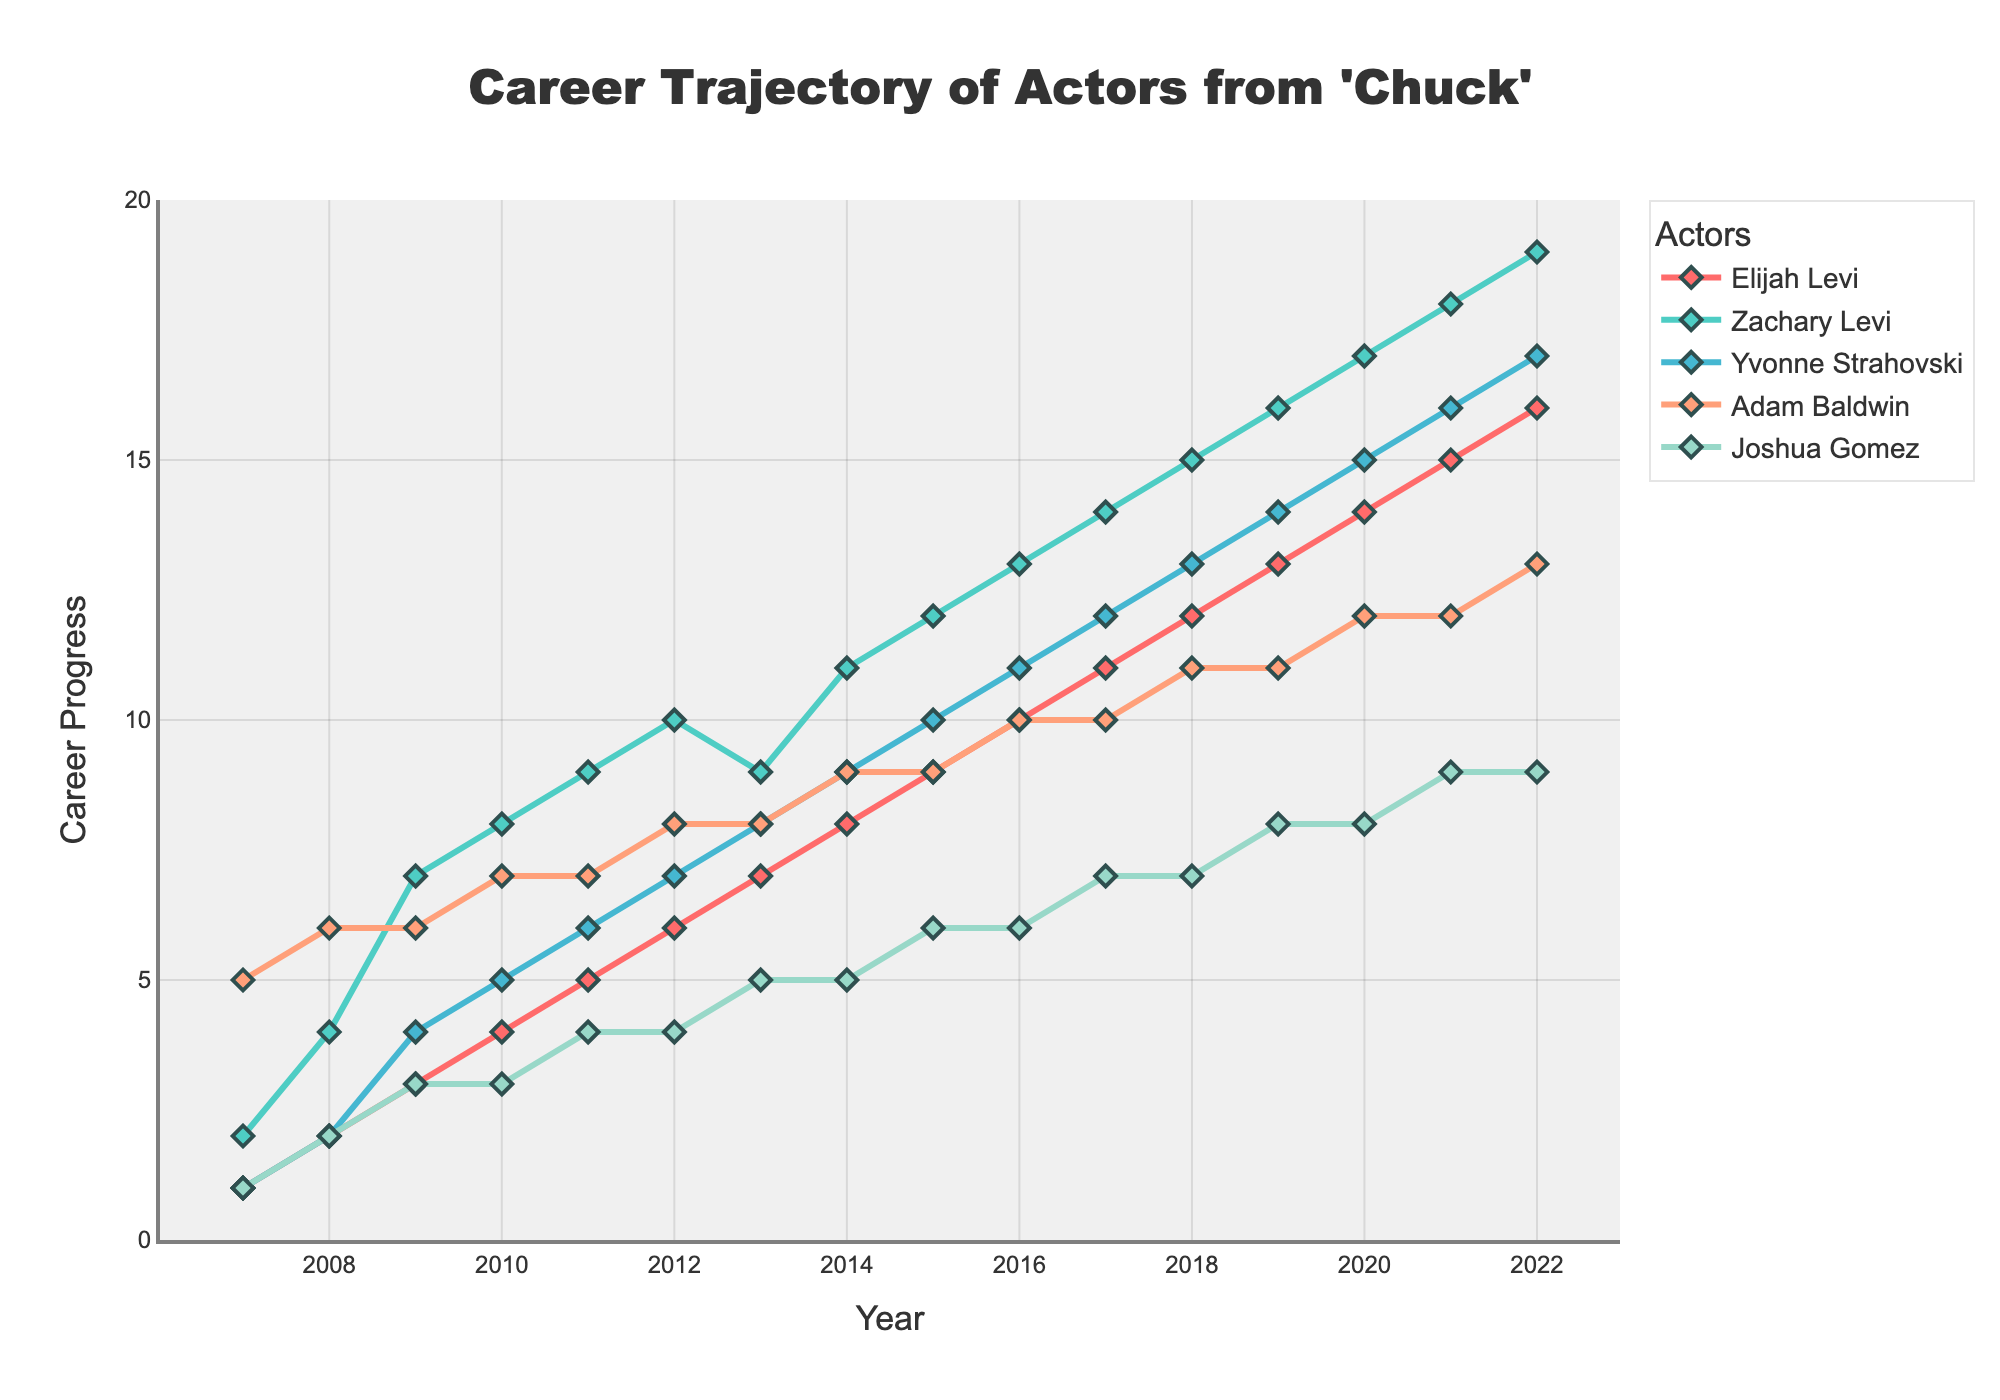Which actor had the highest career progress in 2010? In the year 2010, by examining the heights of the lines, it's clear that Adam Baldwin had the highest career progress as his line is the tallest.
Answer: Adam Baldwin How did Elijah Levi's career progress compare to Joshua Gomez's in 2015? In 2015, Elijah Levi had a career progress of 9, while Joshua Gomez had a career progress of 6. Elijah Levi's progress is greater than Joshua Gomez's.
Answer: Elijah Levi's progress was 3 points higher During which years did Yvonne Strahovski's career progress surpass that of Zachary Levi's? By comparing their trajectories year by year, Yvonne Strahovski's progress surpassed Zachary Levi's in 2007 and 2008 since her line is higher in these years.
Answer: 2007 and 2008 What is the sum of Elijah Levi's career progress in the years 2011 and 2012? The career progress of Elijah Levi in 2011 is 5 and in 2012 is 6. Summing them up: 5 + 6 = 11.
Answer: 11 Which actor showed the most significant increase in career progress between any two consecutive years, and what was the increase? Comparing the increases year by year for all actors, Zachary Levi showed the most significant increase between 2008 and 2009 with an increase of 3 (from 4 to 7).
Answer: Zachary Levi, increase of 3 In which year did Adam Baldwin first see a stall in his career progress? Observing Adam Baldwin's trajectory, he first experienced no increase in career progress from 2009 to 2010 where his value stayed at 6.
Answer: 2010 Who had the lowest career progress in 2020, and what was the value? In 2020, by looking at the heights of the lines, Joshua Gomez had the lowest career progress with a value of 8.
Answer: Joshua Gomez, 8 What is the average career progress of Yvonne Strahovski from 2007 to 2012? Yvonne Strahovski's progress values from 2007 to 2012 are 1, 2, 4, 5, 6, and 7. Summing these values gives 1+2+4+5+6+7 = 25. The average is 25/6 = 4.17.
Answer: 4.17 How many times did Zachary Levi’s career progress exceed 10? By examining Zachary Levi's data points, his career progress exceeded 10 in the years from 2013 to 2022, making it a total of 10 occurrences.
Answer: 10 In 2017, which actor had the closest career progress to 10, and what was their actual value? In 2017, Zachary Levi had a progress value of 14, Yvonne Strahovski 12, Adam Baldwin 10, and Joshua Gomez 7. Adam Baldwin's value of 10 is exactly 10.
Answer: Adam Baldwin, 10 